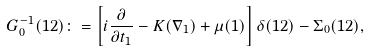<formula> <loc_0><loc_0><loc_500><loc_500>G _ { 0 } ^ { - 1 } ( 1 2 ) \colon = \left [ i \frac { \partial } { \partial t _ { 1 } } - K ( \nabla _ { 1 } ) + \mu ( 1 ) \right ] \delta ( 1 2 ) - \Sigma _ { 0 } ( 1 2 ) ,</formula> 